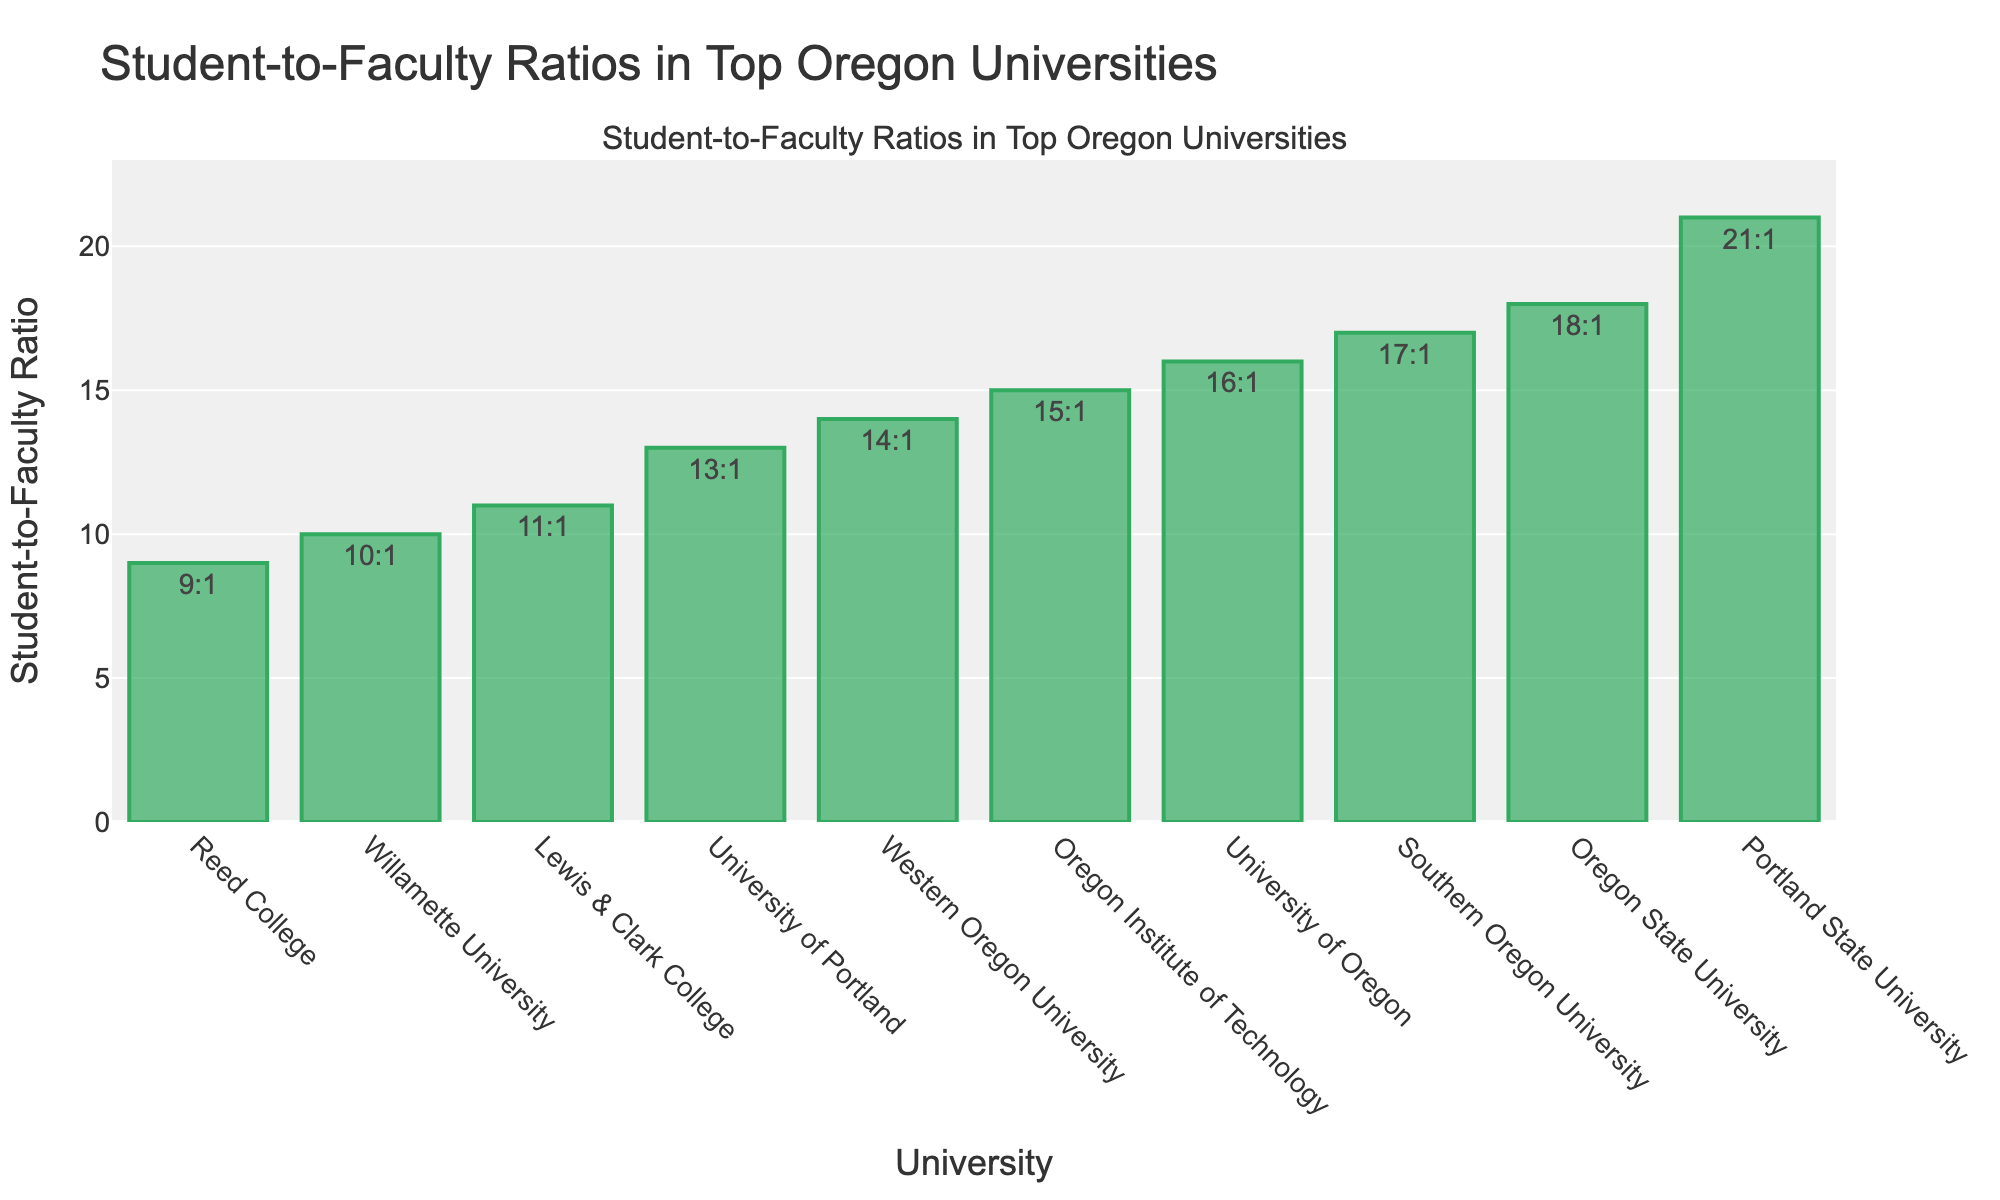Which university has the lowest student-to-faculty ratio? From the bar chart, find the bar with the smallest height. Reed College has the shortest bar, indicating the lowest student-to-faculty ratio.
Answer: Reed College Which university has the highest student-to-faculty ratio? From the bar chart, find the bar with the tallest height. Portland State University has the tallest bar, indicating the highest student-to-faculty ratio.
Answer: Portland State University What is the difference in student-to-faculty ratios between the University of Oregon and Oregon State University? Look at the heights or labels of the bars corresponding to these universities. University of Oregon has a ratio of 16:1 and Oregon State University has 18:1. The difference is 18 - 16.
Answer: 2 Which universities have a student-to-faculty ratio less than 10:1? Identify the bars whose heights are less than 10. Only Reed College meets this criterion with a student-to-faculty ratio of 9:1.
Answer: Reed College What is the average student-to-faculty ratio of all listed universities? Sum the student-to-faculty ratios of all universities and divide by the number of universities. (16+18+21+9+11+10+13+15+14+17)/10 = 144/10 = 14.4
Answer: 14.4 Which university has a student-to-faculty ratio closest to the average ratio of all the universities listed? Calculate the average ratio 14.4. Compare the bars to find the closest value. The University of Portland has a ratio of 13:1, which is closest to 14.4.
Answer: University of Portland How much higher is the student-to-faculty ratio at Portland State University compared to Willamette University? Compare the heights or labels of the bars for these universities. Portland State University has a ratio of 21:1, and Willamette University has a ratio of 10:1. The difference is 21 - 10.
Answer: 11 Arrange the universities with a student-to-faculty ratio of 15:1 or higher in ascending order. Identify the bars with ratios of 15:1 or higher and sort them. Oregon Institute of Technology (15:1), Southern Oregon University (17:1), Oregon State University (18:1), Portland State University (21:1).
Answer: Oregon Institute of Technology, Southern Oregon University, Oregon State University, Portland State University 